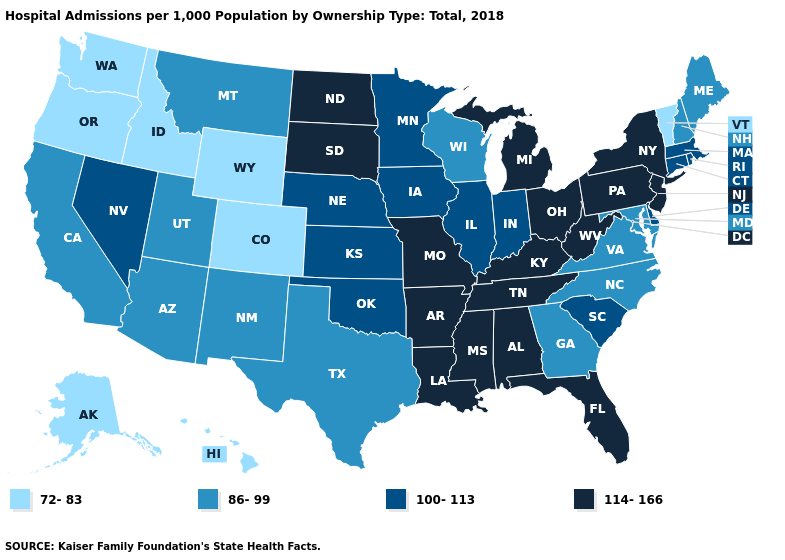Name the states that have a value in the range 100-113?
Concise answer only. Connecticut, Delaware, Illinois, Indiana, Iowa, Kansas, Massachusetts, Minnesota, Nebraska, Nevada, Oklahoma, Rhode Island, South Carolina. Name the states that have a value in the range 86-99?
Answer briefly. Arizona, California, Georgia, Maine, Maryland, Montana, New Hampshire, New Mexico, North Carolina, Texas, Utah, Virginia, Wisconsin. Among the states that border Montana , which have the highest value?
Keep it brief. North Dakota, South Dakota. Which states have the lowest value in the MidWest?
Write a very short answer. Wisconsin. What is the lowest value in states that border New Mexico?
Be succinct. 72-83. What is the highest value in states that border New Mexico?
Keep it brief. 100-113. Is the legend a continuous bar?
Short answer required. No. What is the lowest value in the South?
Keep it brief. 86-99. Does Kansas have the highest value in the MidWest?
Concise answer only. No. What is the value of Louisiana?
Answer briefly. 114-166. Does North Carolina have the same value as New Mexico?
Short answer required. Yes. Which states have the highest value in the USA?
Write a very short answer. Alabama, Arkansas, Florida, Kentucky, Louisiana, Michigan, Mississippi, Missouri, New Jersey, New York, North Dakota, Ohio, Pennsylvania, South Dakota, Tennessee, West Virginia. Which states have the lowest value in the USA?
Concise answer only. Alaska, Colorado, Hawaii, Idaho, Oregon, Vermont, Washington, Wyoming. Does Louisiana have the lowest value in the USA?
Short answer required. No. What is the value of Michigan?
Answer briefly. 114-166. 